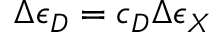Convert formula to latex. <formula><loc_0><loc_0><loc_500><loc_500>\Delta \epsilon _ { D } = c _ { D } \Delta \epsilon _ { X }</formula> 